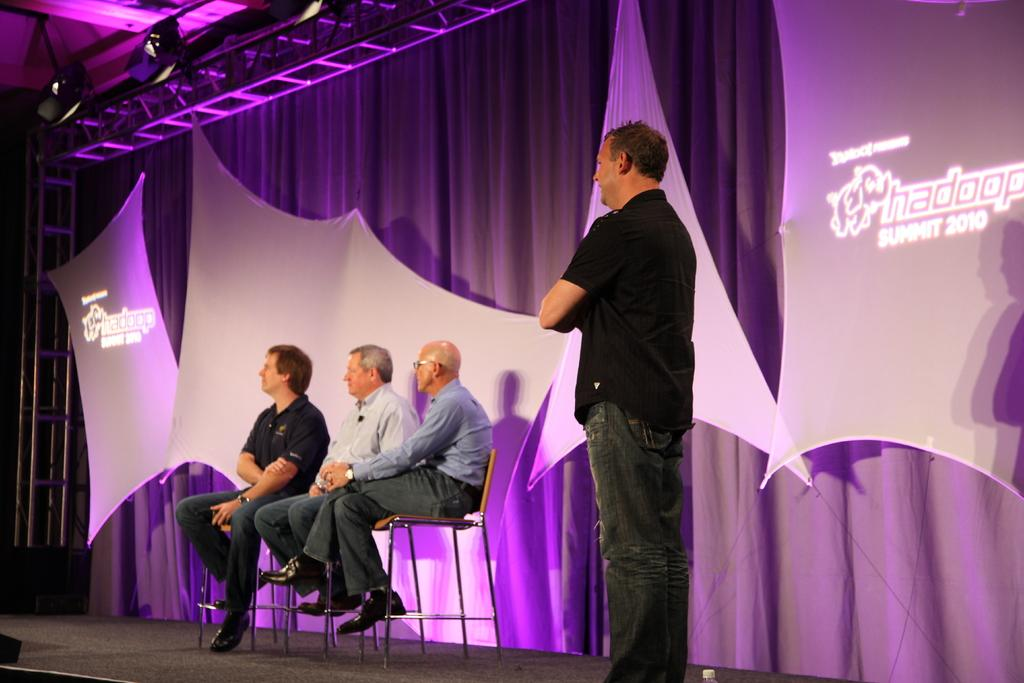What are the people in the image doing? The people in the image are sitting on chairs. Is there anyone standing in the image? Yes, one person is standing next to the sitting people. What can be seen in the background of the image? There is cloth and boards visible in the background. What type of cheese is being served on the trail in the image? There is no trail or cheese present in the image. What flavor of eggnog is being consumed by the people in the image? There is no eggnog present in the image. 